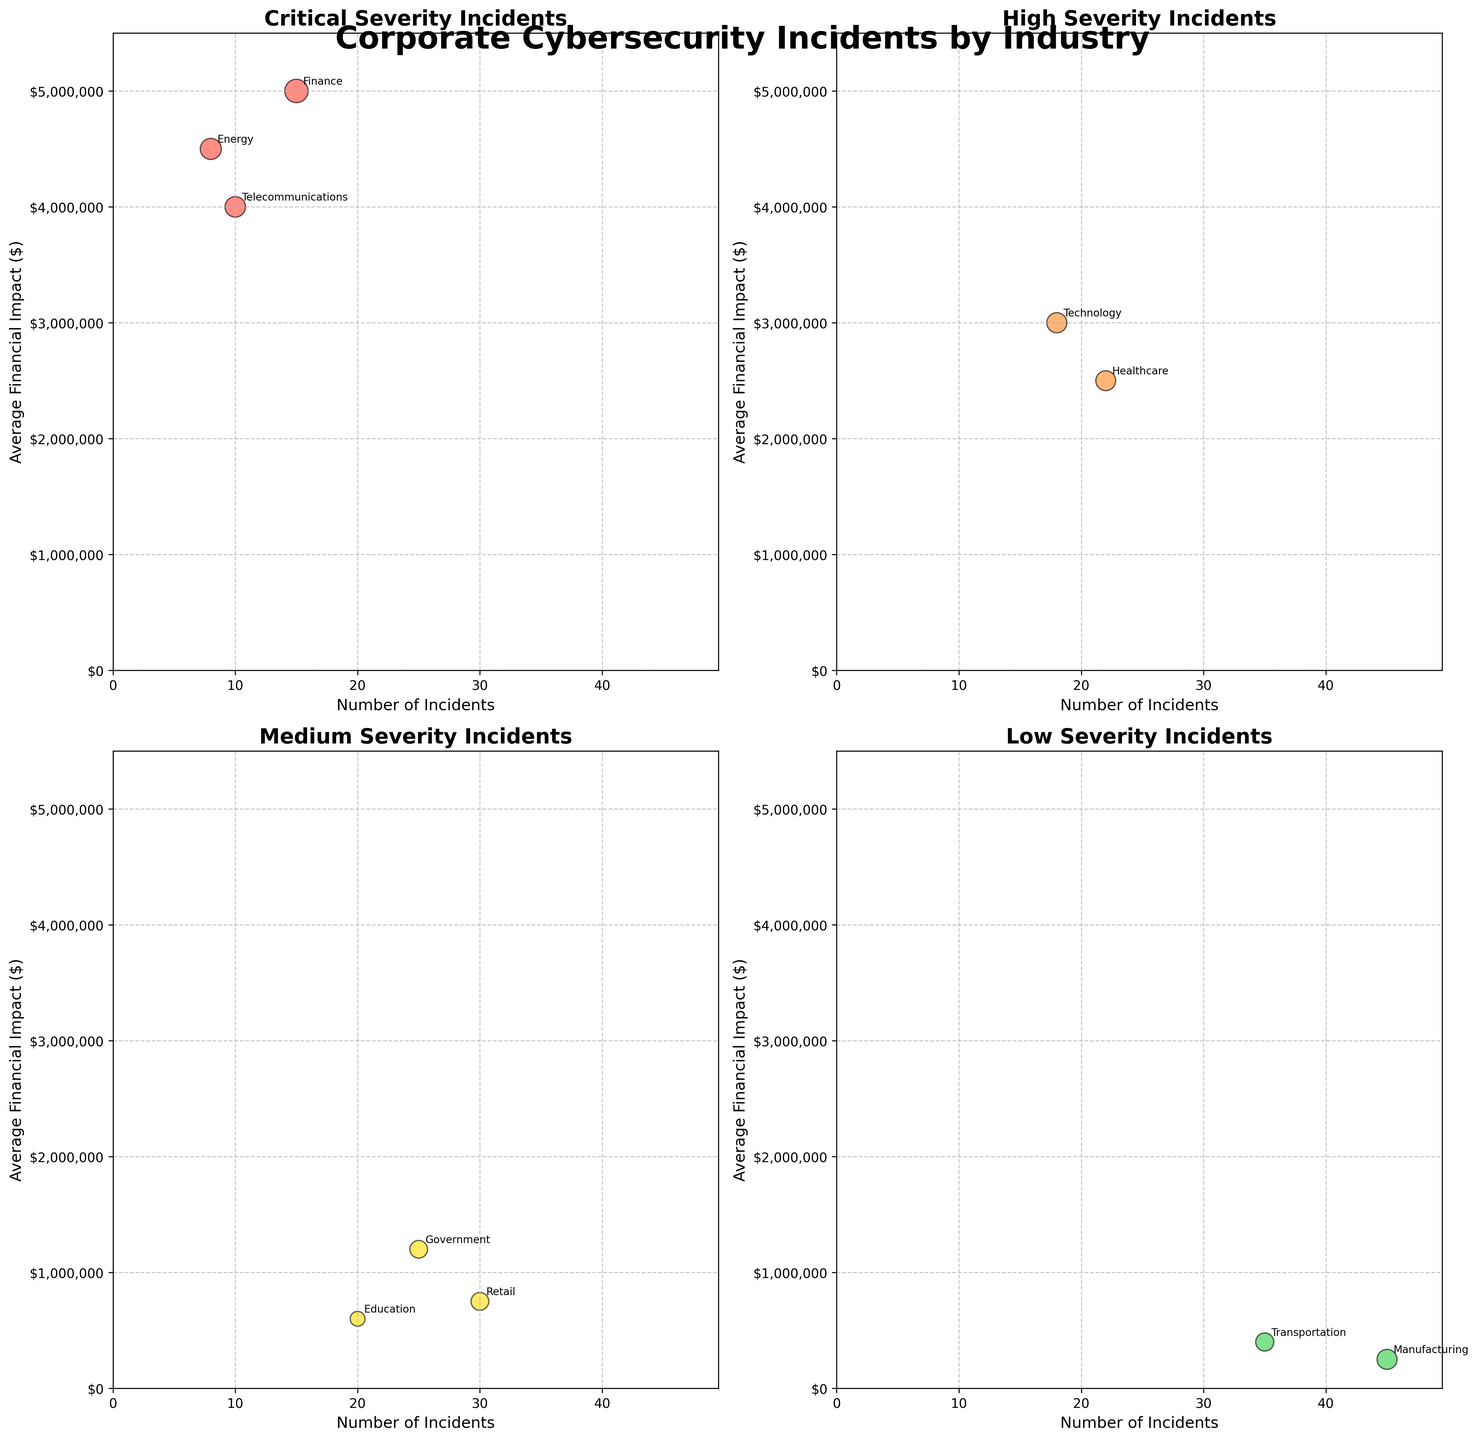Which industry has the highest number of incidents in the Healthcare sector? By looking at the Healthcare sector in the High severity subplot, we see that the y-coordinate for the 'Number of Incidents' is 22. Therefore, Healthcare has 22 incidents.
Answer: 22 What is the average financial impact for the Critical severity incidents in the Finance industry? Looking at the Critical subplot, the Finance industry's bubble has a y-coordinate that corresponds to the average financial impact, which is $5,000,000.
Answer: $5,000,000 Which sector has the least number of incidents in the Critical severity category? By examining the Critical severity subplot, the sector with the least number of incidents is Energy, with 8 incidents.
Answer: Energy Compare the average financial impact between Critical incidents in the Finance sector and Critical incidents in the Telecommunications sector. Which one is higher? Finance has an average financial impact of $5,000,000, whereas Telecommunications has $4,000,000. Since 5,000,000 > 4,000,000, Finance is higher.
Answer: Finance In which sector do Medium severity incidents have the greatest average financial impact? In the Medium severity subplot, Government, Education, and Retail are present. By comparing their y-coordinates, Government has the highest average financial impact at $1,200,000.
Answer: Government How many sectors are represented in the Low severity subplot? By counting the bubbles in the Low severity subplot, we find there are three sectors: Manufacturing, Transportation, and Retail.
Answer: 3 What is the total number of incidents in sectors with High severity? In the High severity subplot, Healthcare has 22 incidents and Technology has 18 incidents. Summing these up, 22 + 18 = 40.
Answer: 40 Rank the sectors with Critical severity by their average financial impact, from highest to lowest. By examining the Critical severity subplot, the average financial impacts are: Finance ($5,000,000), Energy ($4,500,000), and Telecommunications ($4,000,000). Thus, the order is: Finance, Energy, Telecommunications.
Answer: Finance, Energy, Telecommunications What's the overall trend for incidents with Low severity in terms of the number of incidents versus the average financial impact? By looking at the Low severity subplot, we can observe that as the number of incidents increases (from Transportation to Retail to Manufacturing), the average financial impact tends to decrease. This inverse trend shows that sectors with more incidents have a lower financial impact.
Answer: Inverse relationship Compare the number of incidents in the Government sector to the number of incidents in the Telecommunications sector. Which one is larger and by how much? Government (Medium severity) has 25 incidents while Telecommunications (Critical severity) has 10 incidents. The difference is 25 - 10 = 15, so Government has 15 more incidents.
Answer: Government by 15 